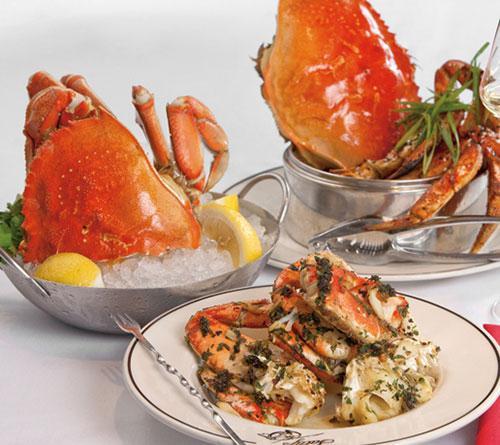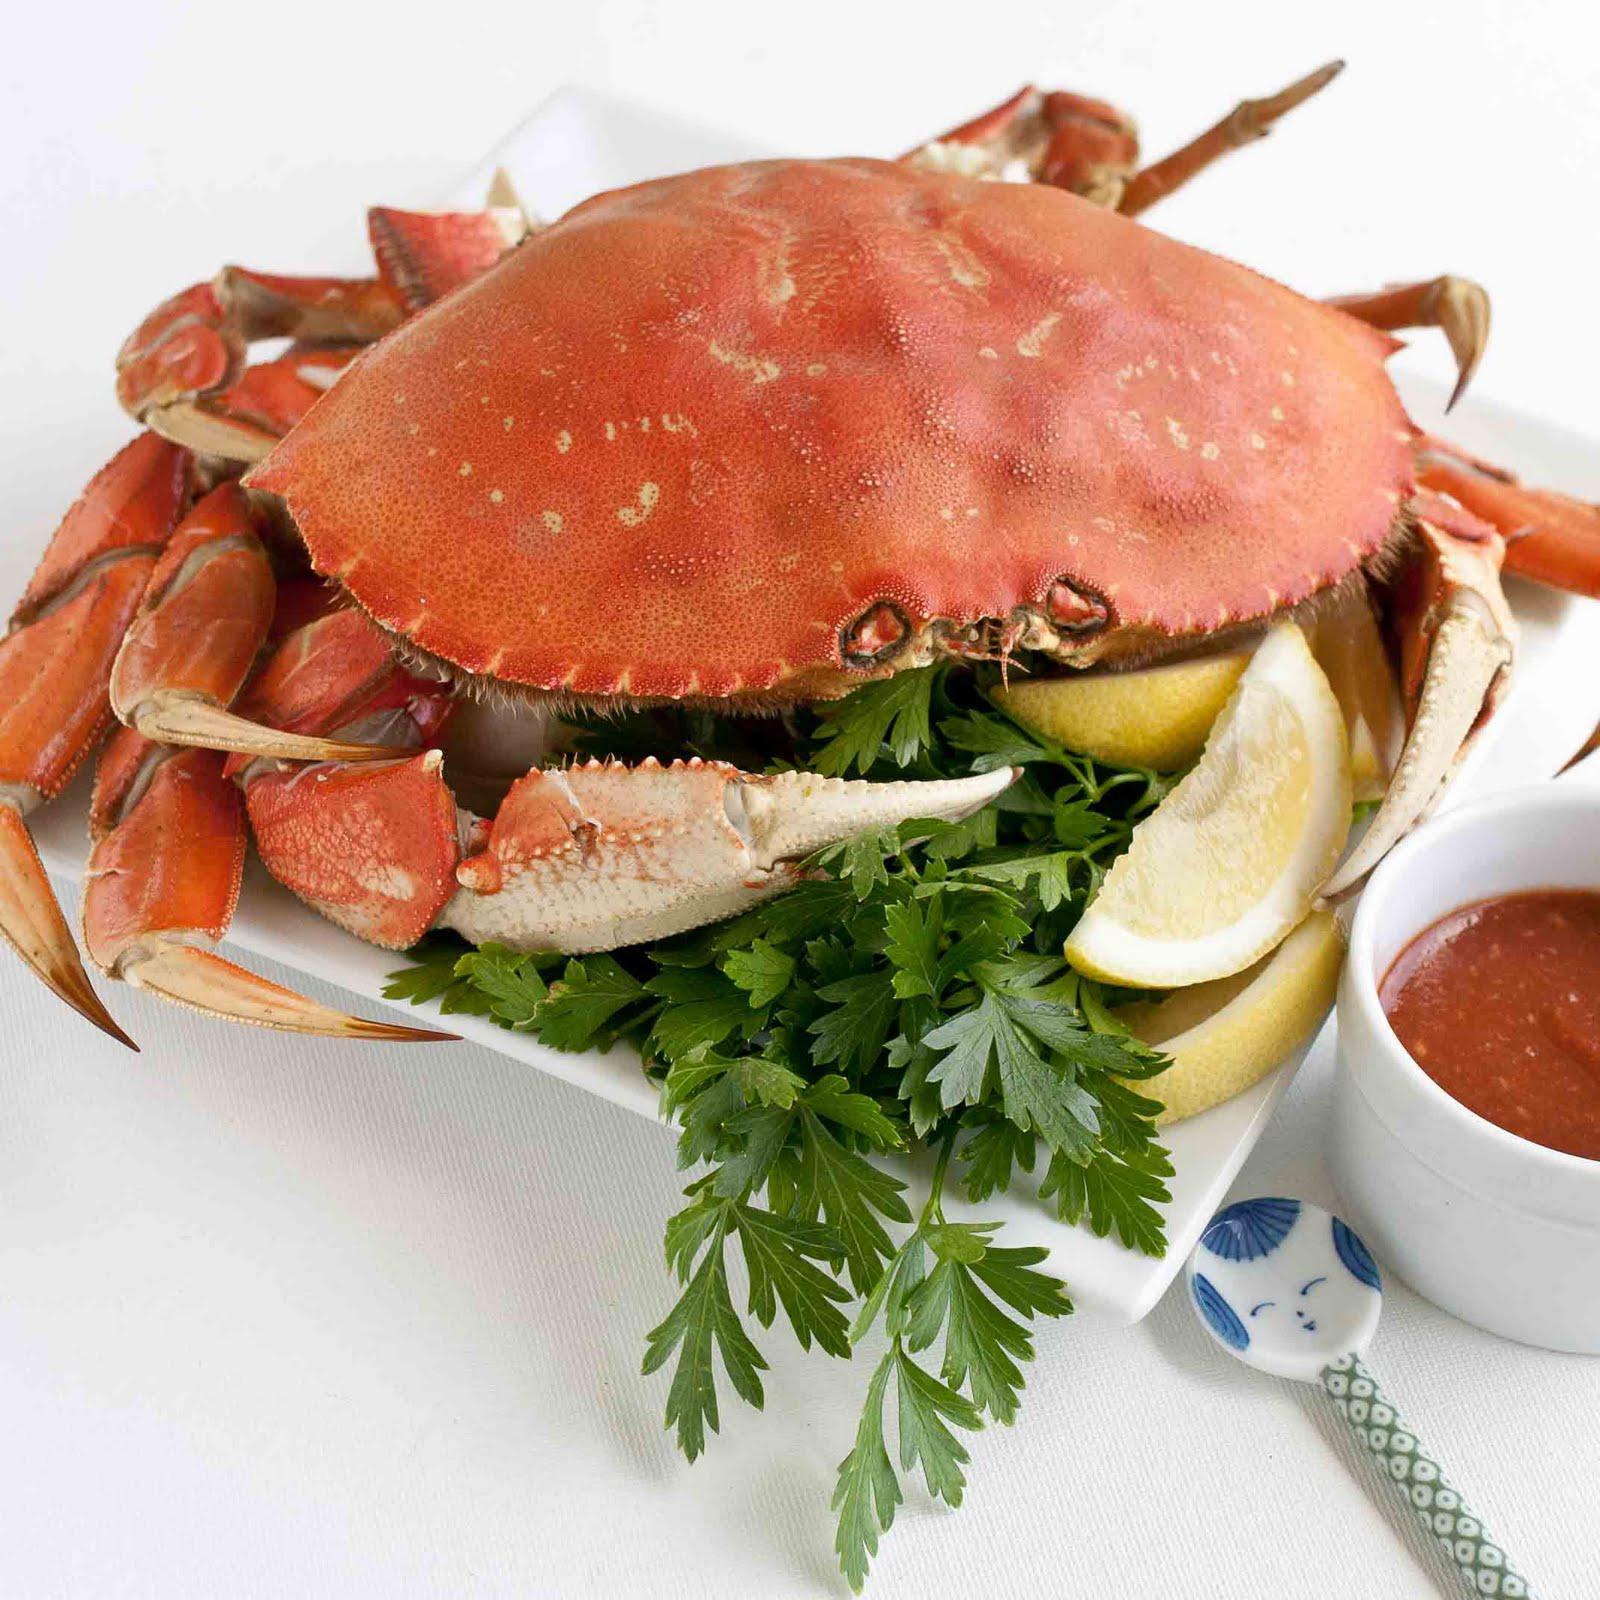The first image is the image on the left, the second image is the image on the right. For the images displayed, is the sentence "There is food other than crab in both images." factually correct? Answer yes or no. Yes. The first image is the image on the left, the second image is the image on the right. Given the left and right images, does the statement "At least one of the images includes a small white dish of dipping sauce next to the plate of crab." hold true? Answer yes or no. Yes. 